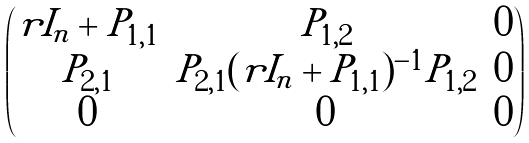Convert formula to latex. <formula><loc_0><loc_0><loc_500><loc_500>\begin{pmatrix} r I _ { n } + P _ { 1 , 1 } & P _ { 1 , 2 } & 0 \\ P _ { 2 , 1 } & P _ { 2 , 1 } ( r I _ { n } + P _ { 1 , 1 } ) ^ { - 1 } P _ { 1 , 2 } & 0 \\ 0 & 0 & 0 \end{pmatrix}</formula> 